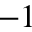Convert formula to latex. <formula><loc_0><loc_0><loc_500><loc_500>- 1</formula> 